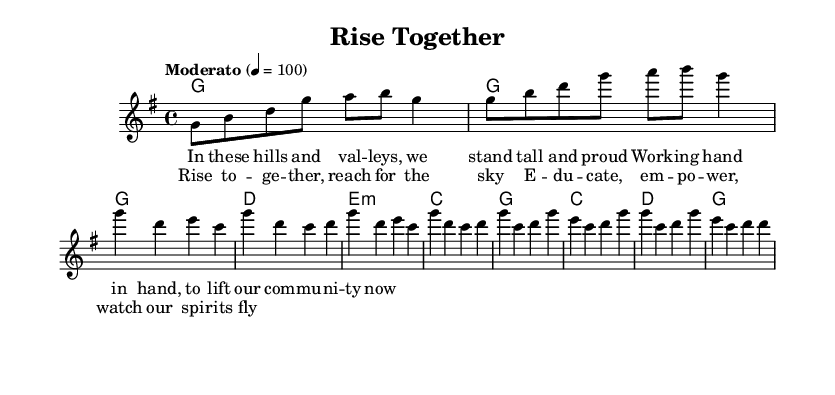What is the key signature of this music? The key signature is G major, which contains one sharp (F#). This is indicated at the beginning of the sheet music.
Answer: G major What is the time signature of this music? The time signature is 4/4, which means there are four beats in each measure and the quarter note receives one beat. This can be seen to the left at the beginning of the score.
Answer: 4/4 What is the tempo marking for the piece? The tempo marking is "Moderato", which indicates a moderate speed. The metronome marking of 100 beats per minute can also be inferred from the tempo indication in the score.
Answer: Moderato How many measures are in the verse section? The verse section consists of four measures, as there are four distinct notations presented in succession. By counting the measures within the verse part of the music, we can see this clearly.
Answer: 4 What is the primary theme of the chorus lyrics? The primary theme of the chorus lyrics revolves around community empowerment and aspiration, as reflected in the idea of rising together and growth. The phrases within the lyrics express a collective effort towards education and upliftment.
Answer: Empowerment Which musical element is most prominent in the chorus compared to the verse? The musical element most prominent in the chorus is dynamics, as it typically showcases a more robust and uplifting melody which creates a feeling of excitement and motivation. The melody rises and becomes more emphatic.
Answer: Dynamics What lyrical content is emphasized in the introduction? The lyrical content emphasizes the community's strength and unity in the introduction, setting the stage for the positive themes explored throughout the song. This sets a tone of pride that resonates throughout the piece.
Answer: Community strength 